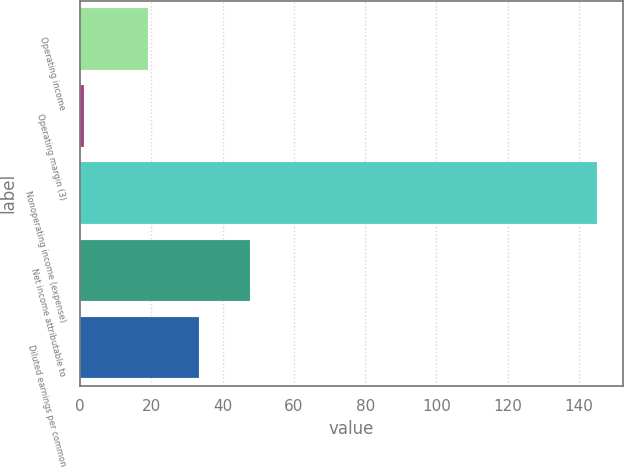<chart> <loc_0><loc_0><loc_500><loc_500><bar_chart><fcel>Operating income<fcel>Operating margin (3)<fcel>Nonoperating income (expense)<fcel>Net income attributable to<fcel>Diluted earnings per common<nl><fcel>19<fcel>1<fcel>145<fcel>47.8<fcel>33.4<nl></chart> 